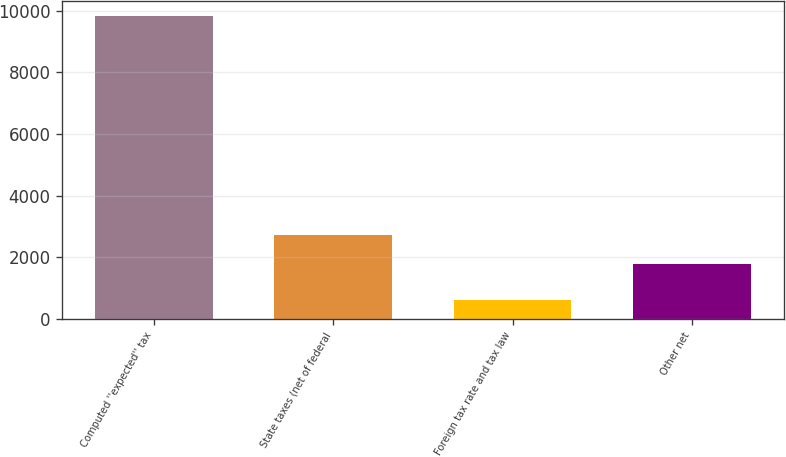Convert chart to OTSL. <chart><loc_0><loc_0><loc_500><loc_500><bar_chart><fcel>Computed ''expected'' tax<fcel>State taxes (net of federal<fcel>Foreign tax rate and tax law<fcel>Other net<nl><fcel>9838<fcel>2709<fcel>598<fcel>1785<nl></chart> 